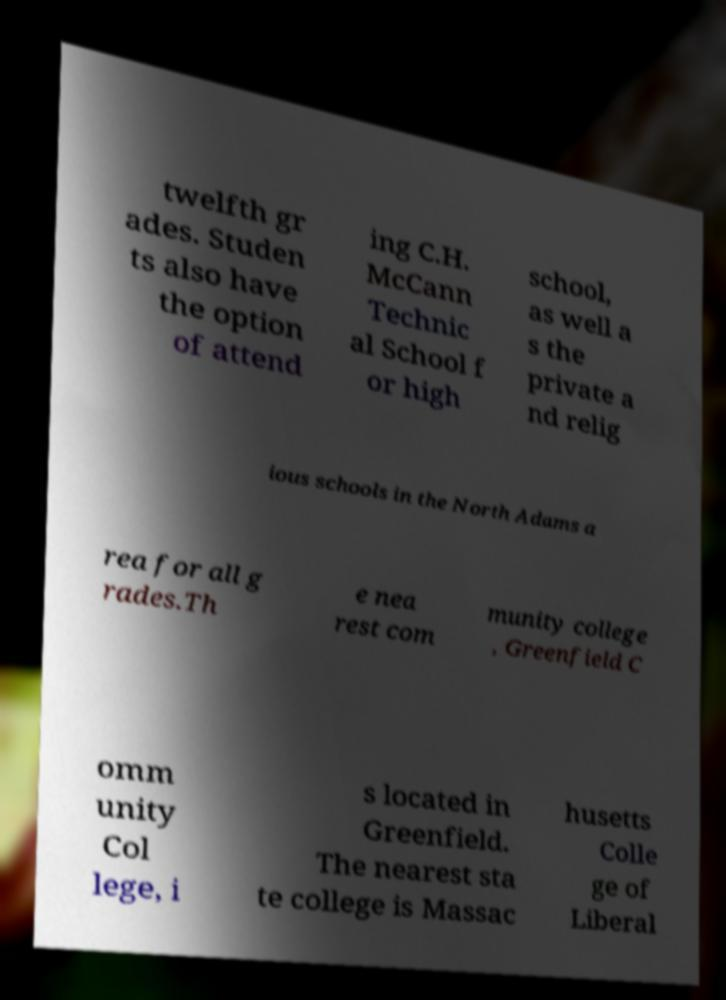For documentation purposes, I need the text within this image transcribed. Could you provide that? twelfth gr ades. Studen ts also have the option of attend ing C.H. McCann Technic al School f or high school, as well a s the private a nd relig ious schools in the North Adams a rea for all g rades.Th e nea rest com munity college , Greenfield C omm unity Col lege, i s located in Greenfield. The nearest sta te college is Massac husetts Colle ge of Liberal 